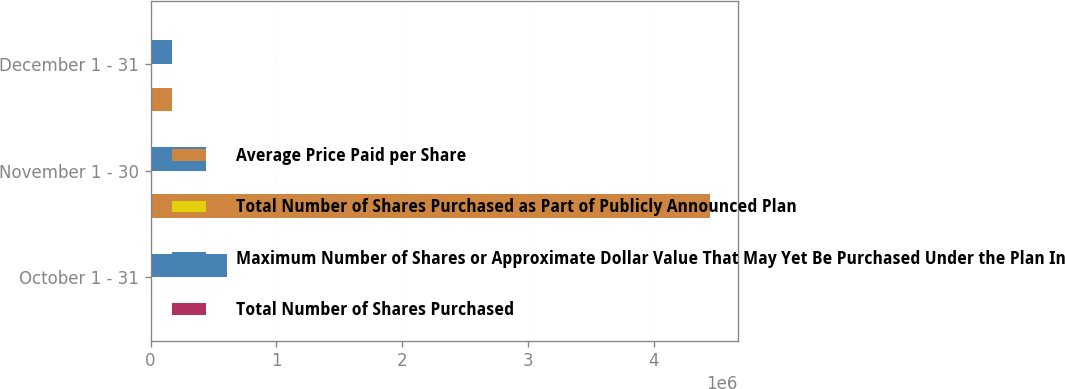<chart> <loc_0><loc_0><loc_500><loc_500><stacked_bar_chart><ecel><fcel>October 1 - 31<fcel>November 1 - 30<fcel>December 1 - 31<nl><fcel>Average Price Paid per Share<fcel>188.7<fcel>4.44362e+06<fcel>168800<nl><fcel>Total Number of Shares Purchased as Part of Publicly Announced Plan<fcel>42.92<fcel>45.98<fcel>45.83<nl><fcel>Maximum Number of Shares or Approximate Dollar Value That May Yet Be Purchased Under the Plan In millions<fcel>605403<fcel>440490<fcel>168800<nl><fcel>Total Number of Shares Purchased<fcel>188.7<fcel>168.4<fcel>160.7<nl></chart> 